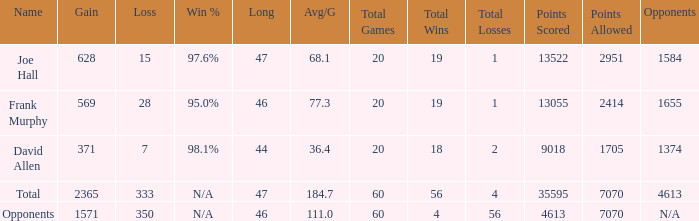How much Loss has a Gain smaller than 1571, and a Long smaller than 47, and an Avg/G of 36.4? 1.0. 